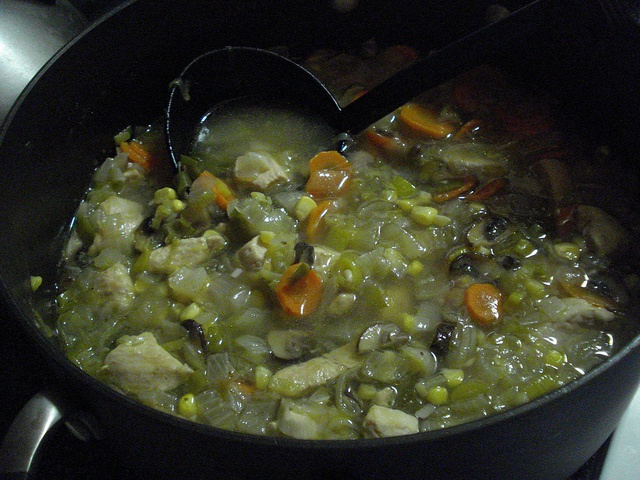Describe the objects in this image and their specific colors. I can see bowl in black, darkgreen, gray, darkblue, and olive tones, spoon in darkblue, black, gray, navy, and darkgreen tones, carrot in darkblue, olive, and gray tones, carrot in darkblue, olive, maroon, and gray tones, and carrot in darkblue, olive, maroon, and black tones in this image. 